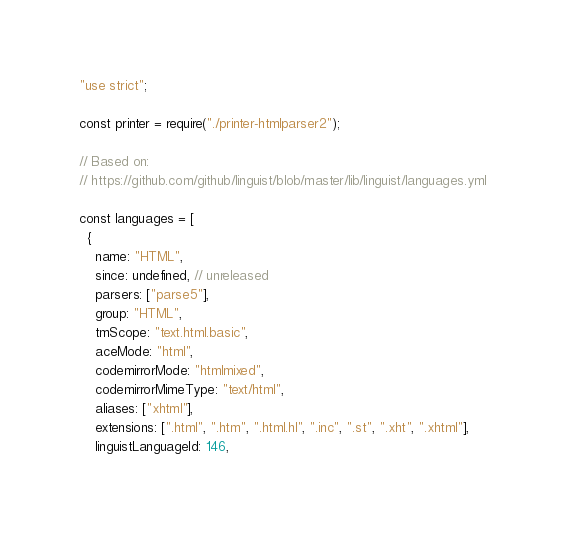<code> <loc_0><loc_0><loc_500><loc_500><_JavaScript_>"use strict";

const printer = require("./printer-htmlparser2");

// Based on:
// https://github.com/github/linguist/blob/master/lib/linguist/languages.yml

const languages = [
  {
    name: "HTML",
    since: undefined, // unreleased
    parsers: ["parse5"],
    group: "HTML",
    tmScope: "text.html.basic",
    aceMode: "html",
    codemirrorMode: "htmlmixed",
    codemirrorMimeType: "text/html",
    aliases: ["xhtml"],
    extensions: [".html", ".htm", ".html.hl", ".inc", ".st", ".xht", ".xhtml"],
    linguistLanguageId: 146,</code> 